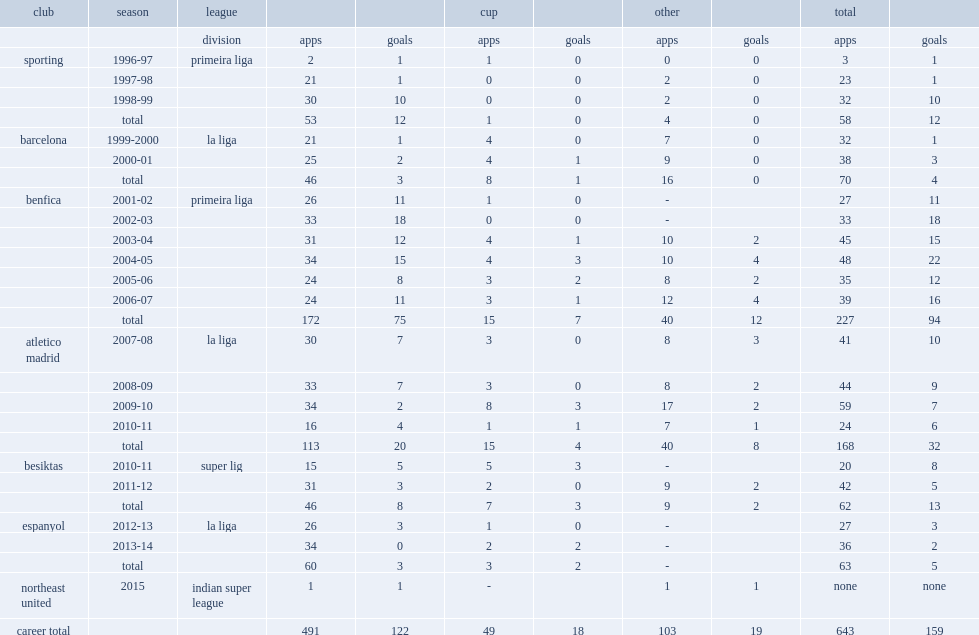In 2015, which league did simao play for club northeast united fc simao? Indian super league. 